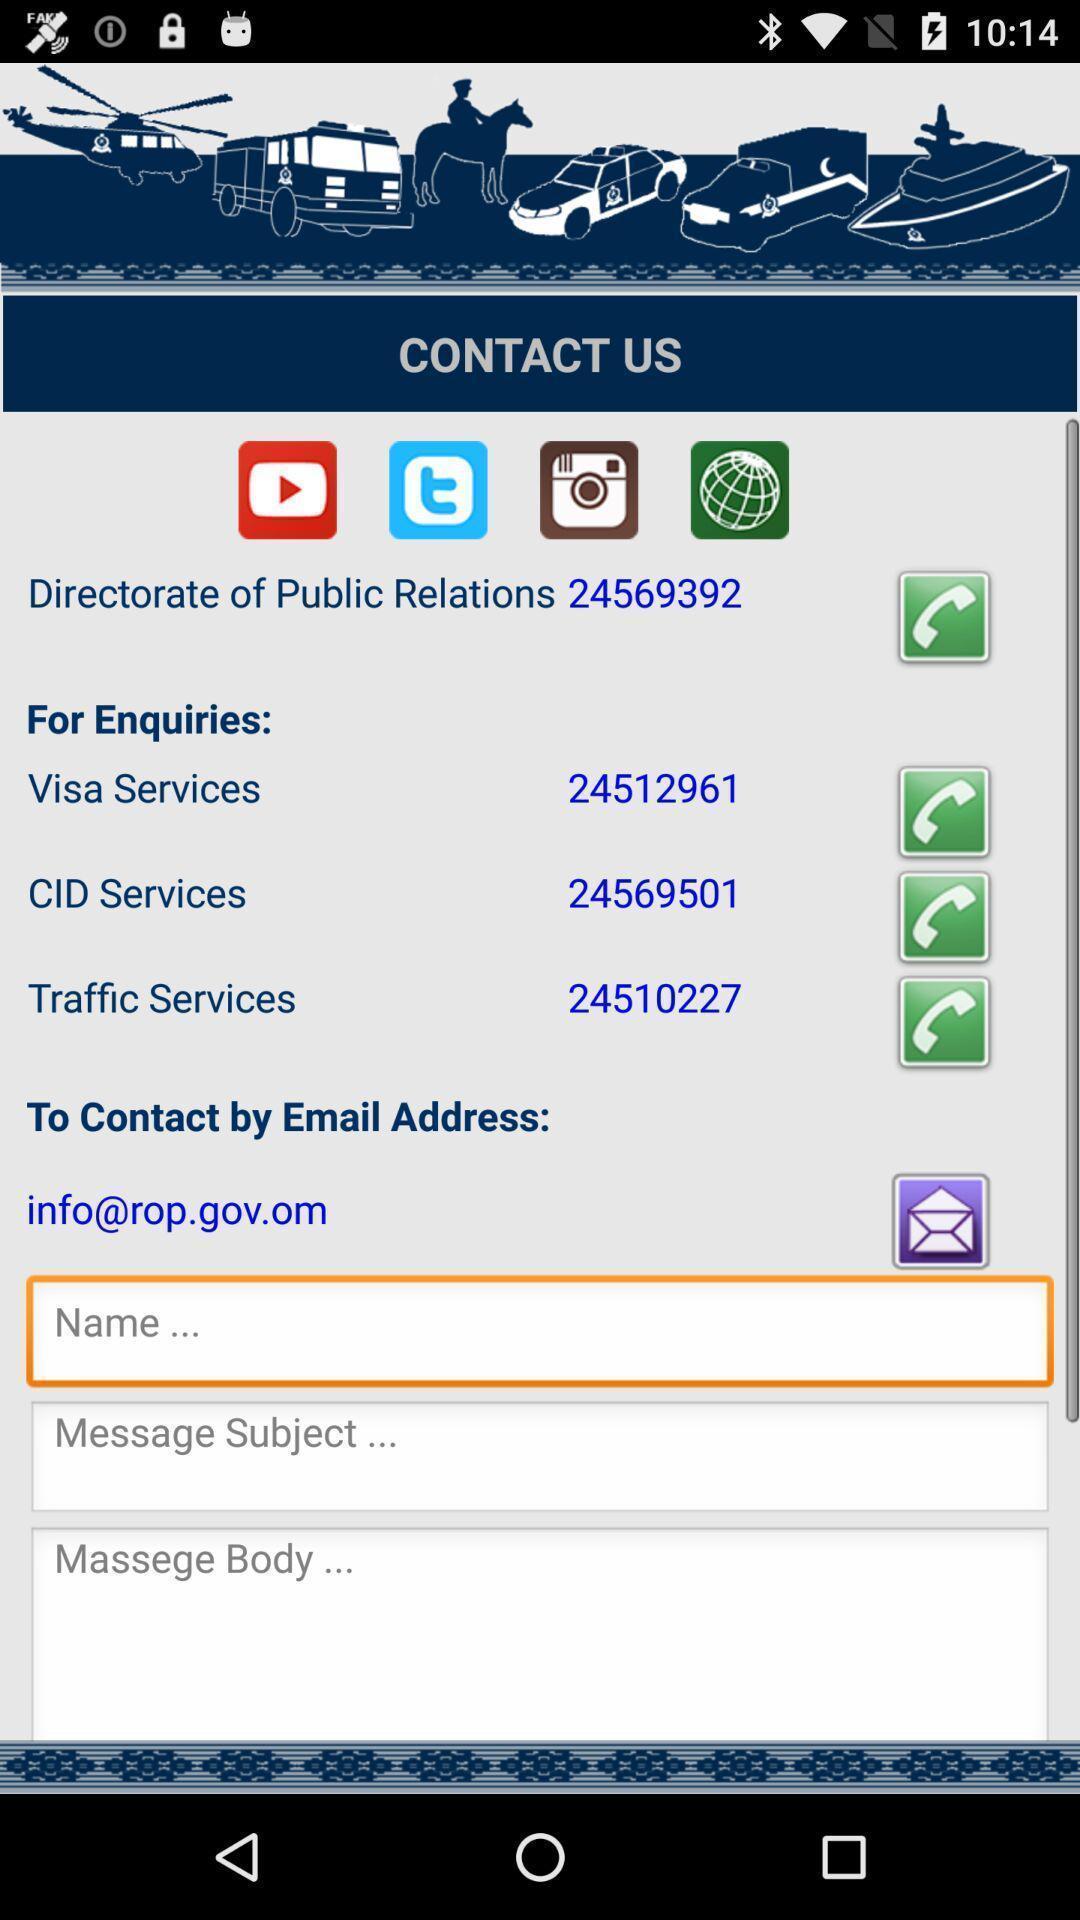Provide a description of this screenshot. Page is showing details to contact us. 